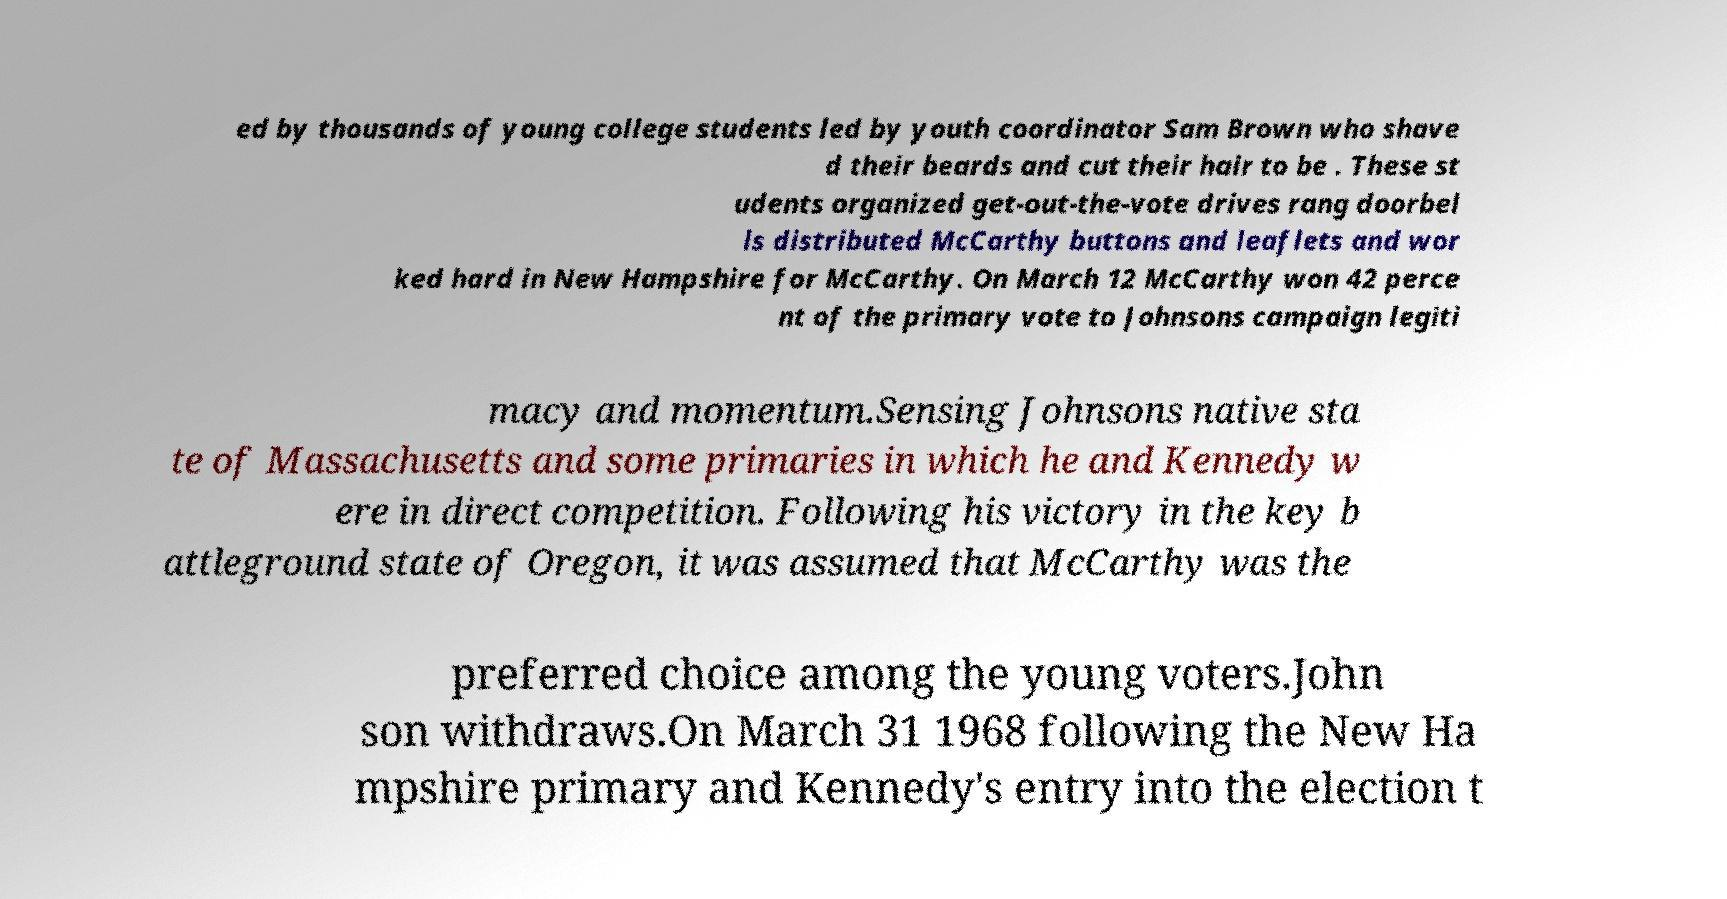Please identify and transcribe the text found in this image. ed by thousands of young college students led by youth coordinator Sam Brown who shave d their beards and cut their hair to be . These st udents organized get-out-the-vote drives rang doorbel ls distributed McCarthy buttons and leaflets and wor ked hard in New Hampshire for McCarthy. On March 12 McCarthy won 42 perce nt of the primary vote to Johnsons campaign legiti macy and momentum.Sensing Johnsons native sta te of Massachusetts and some primaries in which he and Kennedy w ere in direct competition. Following his victory in the key b attleground state of Oregon, it was assumed that McCarthy was the preferred choice among the young voters.John son withdraws.On March 31 1968 following the New Ha mpshire primary and Kennedy's entry into the election t 